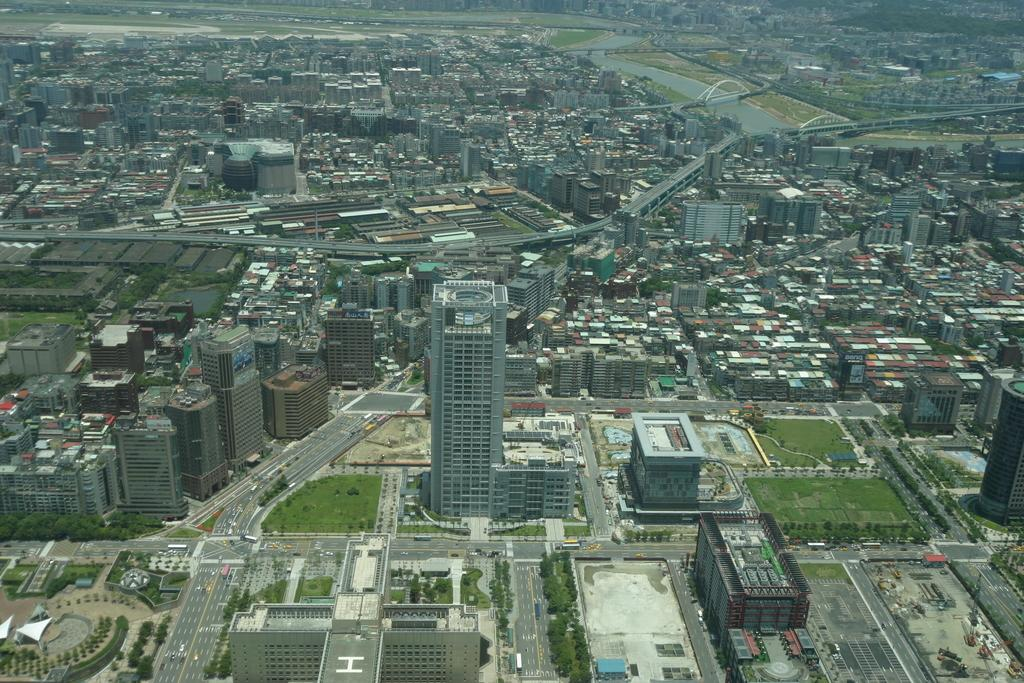What type of view is shown in the image? The image is an aerial view. What natural elements can be seen in the image? There are trees visible in the image. What man-made structures are present in the image? Skyscrapers are present in the image. How does the zephyr affect the balance of the dock in the image? There is no dock present in the image, and therefore no zephyr or balance to consider. 